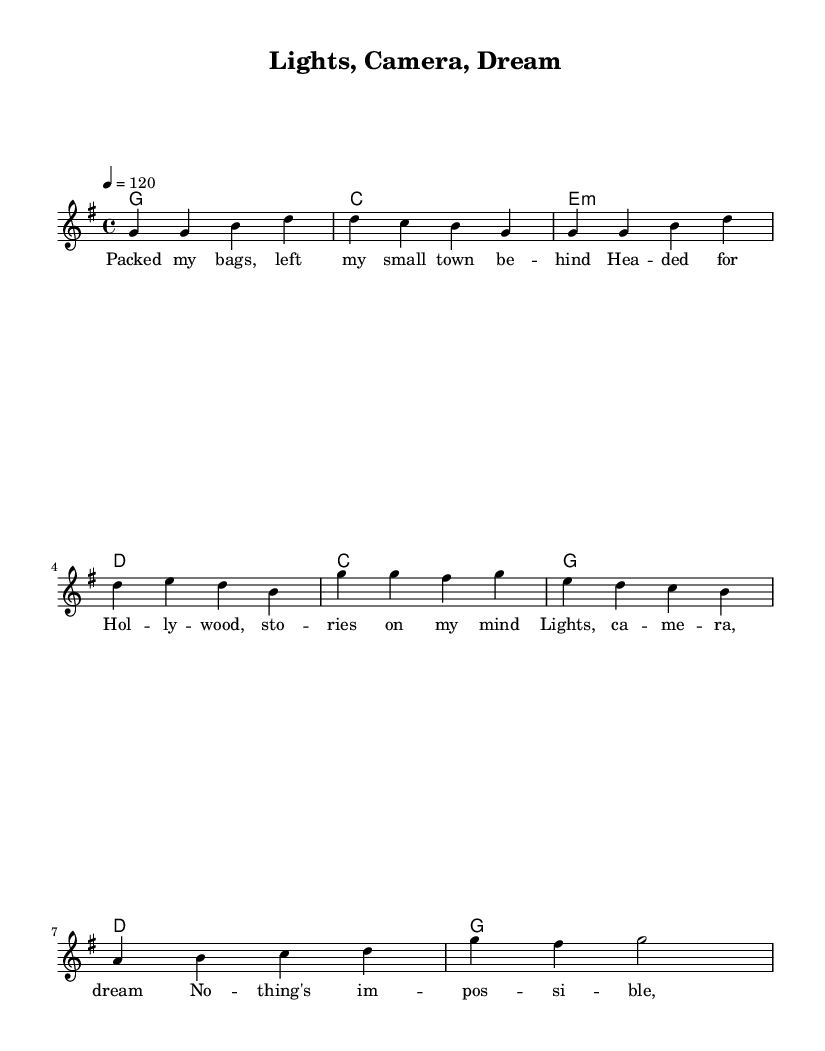What is the key signature of this music? The key signature is G major, which has one sharp (F#).
Answer: G major What is the time signature of this music? The time signature is 4/4, meaning there are four beats in a measure and a quarter note gets one beat.
Answer: 4/4 What is the tempo marking of this piece? The tempo marking is 120 beats per minute, indicating a moderate tempo.
Answer: 120 What chords are used in the verse? The chords used in the verse are G, C, E minor, and D, as indicated in the harmonies section.
Answer: G, C, E minor, D What is the primary theme of the lyrics? The primary theme of the lyrics is pursuing dreams, specifically referencing a journey to Hollywood for storytelling aspirations.
Answer: Pursuing dreams How many measures does the chorus have? The chorus has 4 measures, as determined by counting the distinct musical phrases in the chorus section.
Answer: 4 